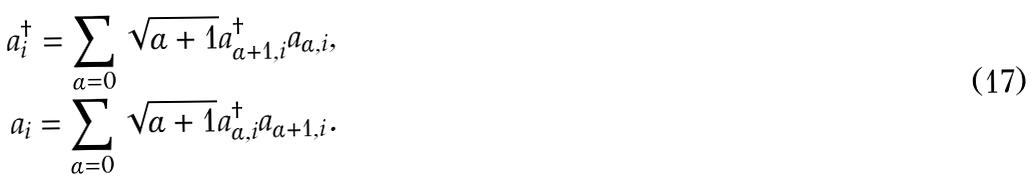<formula> <loc_0><loc_0><loc_500><loc_500>a _ { i } ^ { \dag } = \sum _ { \alpha = 0 } \sqrt { \alpha + 1 } a _ { \alpha + 1 , i } ^ { \dag } a _ { \alpha , i } , \\ a _ { i } = \sum _ { \alpha = 0 } \sqrt { \alpha + 1 } a _ { \alpha , i } ^ { \dag } a _ { \alpha + 1 , i } .</formula> 